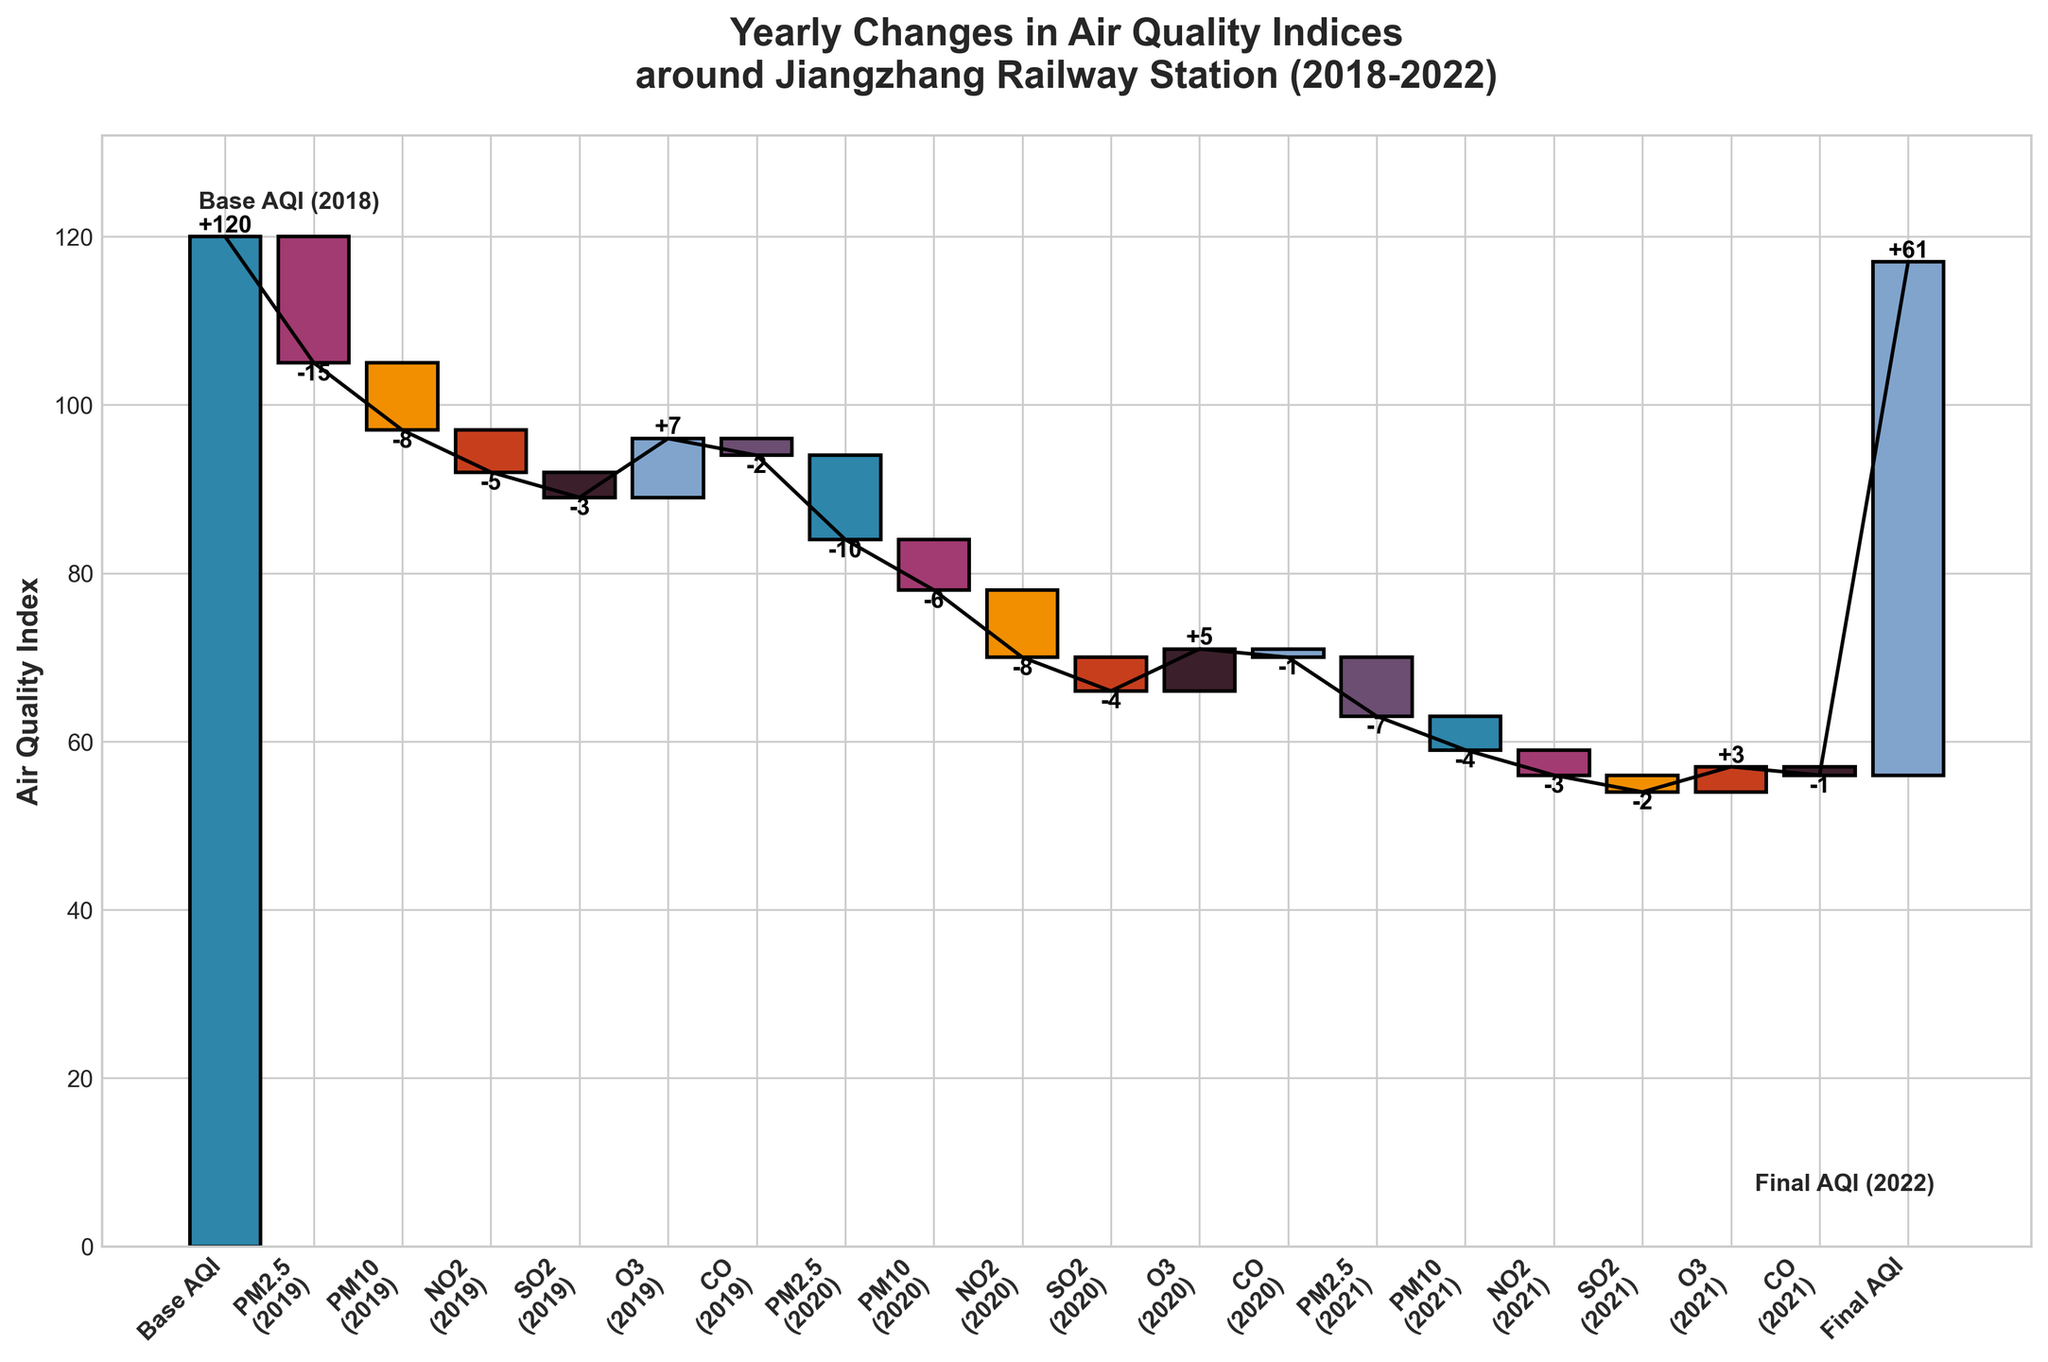What is the title of the figure? The title is usually found at the top of the chart and states what the chart is about.
Answer: Yearly Changes in Air Quality Indices around Jiangzhang Railway Station (2018-2022) What is the base AQI value in 2018? The base AQI value is provided in the first bar of the chart.
Answer: 120 Which year had the largest decrease in PM2.5 levels? Compare the changes in PM2.5 levels for each year by examining the respective bars labeled PM2.5.
Answer: 2020 How did the levels of O3 change from 2019 to 2021? Identify the bars labeled O3 for each year and then look at the changes in their heights. Calculate the values for 2019, 2020, and 2021 which are +7, +5, and +3 respectively.
Answer: Decreasing What was the AQI value at the final year shown in the figure? The final AQI value is provided in the last bar of the chart.
Answer: 61 Compare the changes in CO levels between 2019 and 2021, which year had a lesser decrease? Examine the changes in CO levels for each year and compare the absolute values of the changes. For 2019 it is -2 and for 2021 it is -1.
Answer: 2021 What is the overall change in AQI from 2018 to 2022? Subtract the final AQI (2022) from the base AQI (2018) to determine the overall change. The values are 120 in 2018 and 61 in 2022, so the overall change is 120 - 61 = 59.
Answer: -59 In 2020, which pollutant contributed the highest reduction in the AQI? Assess the contributions from different pollutants for the year 2020, then identify the bar with the highest negative value (PM2.5: -10, PM10: -6, NO2: -8, SO2: -4, O3: +5, CO: -1).
Answer: PM2.5 What is the cumulative reduction in AQI due to all pollutants in 2019? Add the negative contributions from all pollutants for the year 2019 (PM2.5: -15, PM10: -8, NO2: -5, SO2: -3, CO: -2) and ignore O3 since it increased (+7). (-15) + (-8) + (-5) + (-3) + (-2) = -33.
Answer: -33 